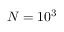<formula> <loc_0><loc_0><loc_500><loc_500>N = 1 0 ^ { 3 }</formula> 